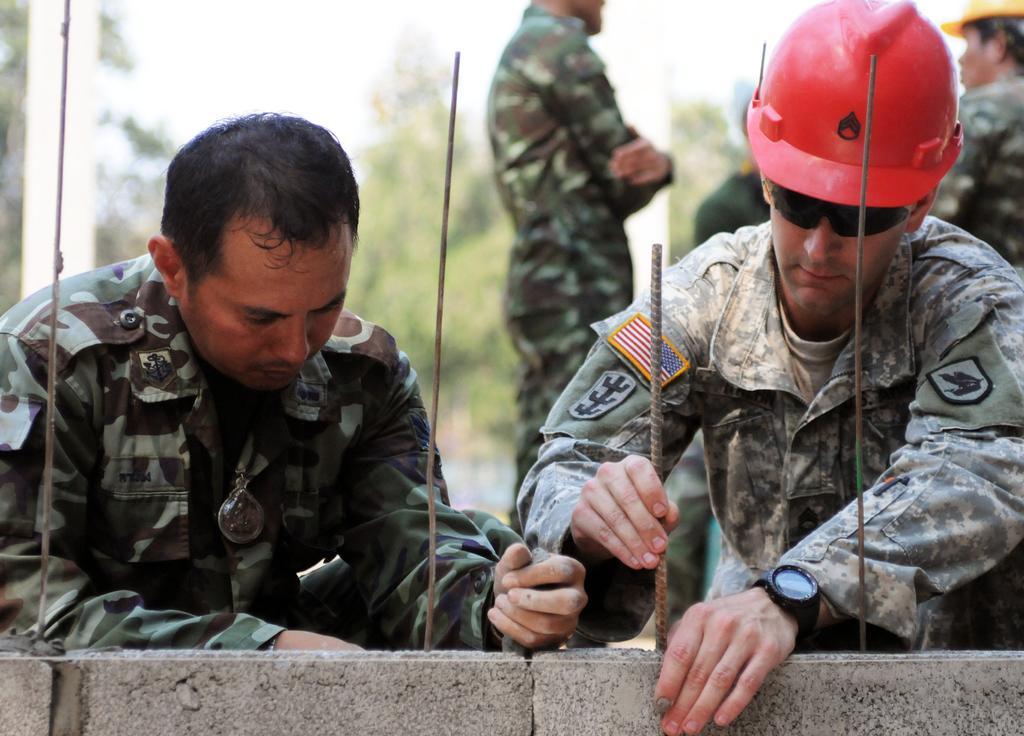Could you give a brief overview of what you see in this image? In this picture I can see the grey color things in front, on which there are 4 rods and behind the rods I can see few persons, who are wearing army uniform and I see that the man on the right is wearing a helmet and shades. I can also see he is holding a rod. I see that it is blurred in the background. 